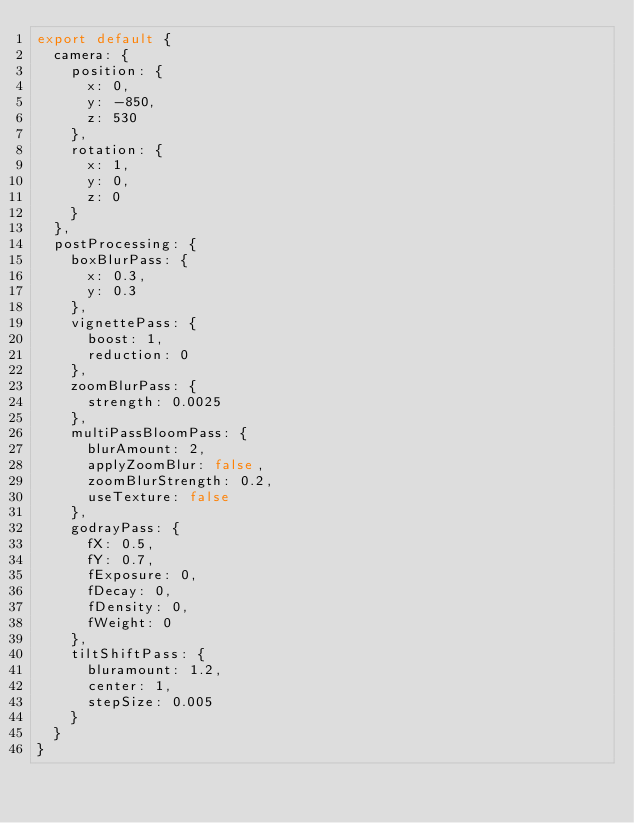Convert code to text. <code><loc_0><loc_0><loc_500><loc_500><_JavaScript_>export default {
  camera: {
    position: {
      x: 0,
      y: -850,
      z: 530
    },
    rotation: {
      x: 1,
      y: 0,
      z: 0
    }
  },
  postProcessing: {
    boxBlurPass: {
      x: 0.3,
      y: 0.3
    },
    vignettePass: {
      boost: 1,
      reduction: 0
    },
    zoomBlurPass: {
      strength: 0.0025
    },
    multiPassBloomPass: {
      blurAmount: 2,
      applyZoomBlur: false,
      zoomBlurStrength: 0.2,
      useTexture: false
    },
    godrayPass: {
      fX: 0.5,
      fY: 0.7,
      fExposure: 0,
      fDecay: 0,
      fDensity: 0,
      fWeight: 0
    },
    tiltShiftPass: {
      bluramount: 1.2,
      center: 1,
      stepSize: 0.005
    }
  }
}
</code> 